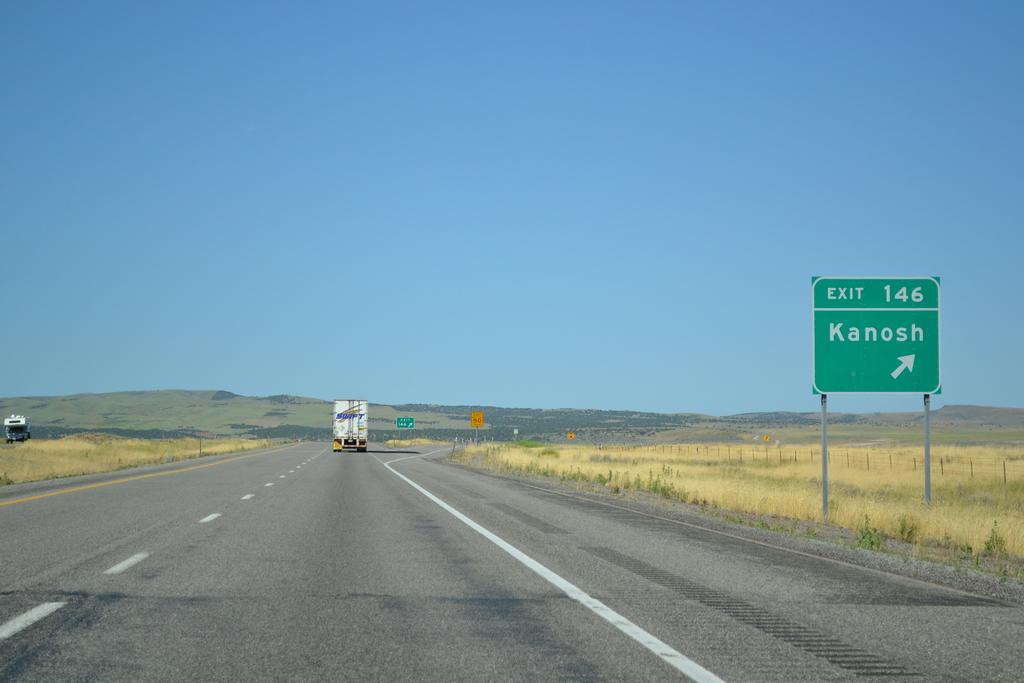What is written on the green sign?
Provide a short and direct response. Kanosh. 